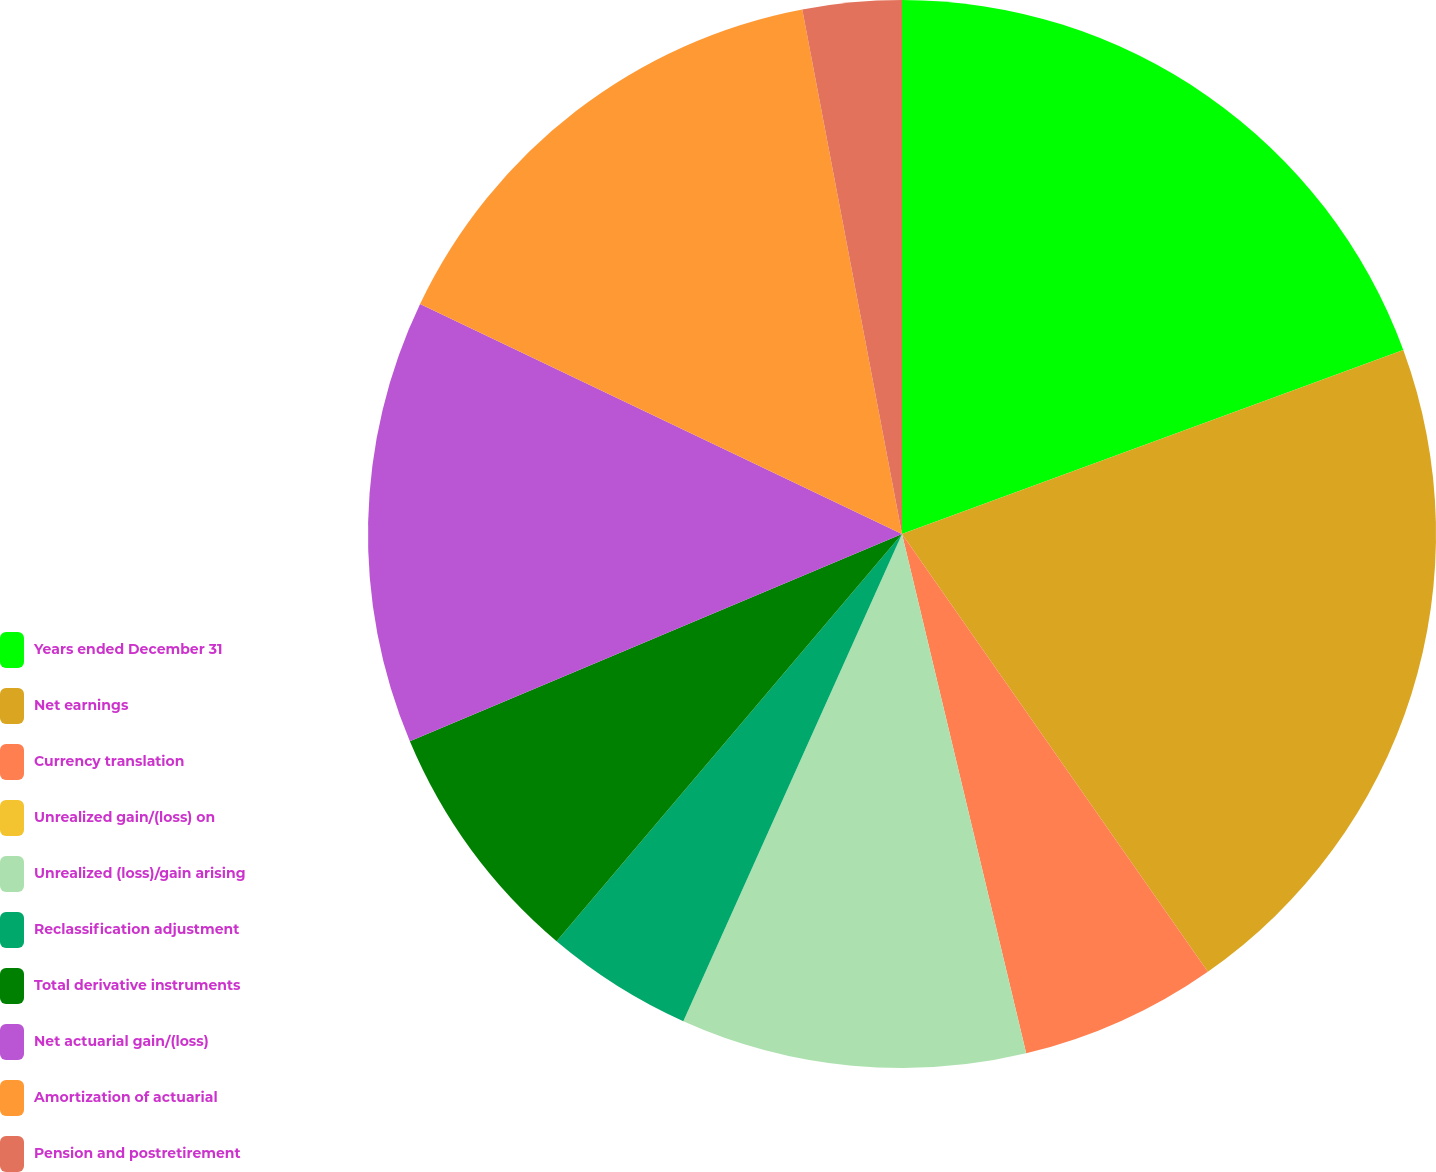<chart> <loc_0><loc_0><loc_500><loc_500><pie_chart><fcel>Years ended December 31<fcel>Net earnings<fcel>Currency translation<fcel>Unrealized gain/(loss) on<fcel>Unrealized (loss)/gain arising<fcel>Reclassification adjustment<fcel>Total derivative instruments<fcel>Net actuarial gain/(loss)<fcel>Amortization of actuarial<fcel>Pension and postretirement<nl><fcel>19.4%<fcel>20.89%<fcel>5.97%<fcel>0.0%<fcel>10.45%<fcel>4.48%<fcel>7.46%<fcel>13.43%<fcel>14.92%<fcel>2.99%<nl></chart> 